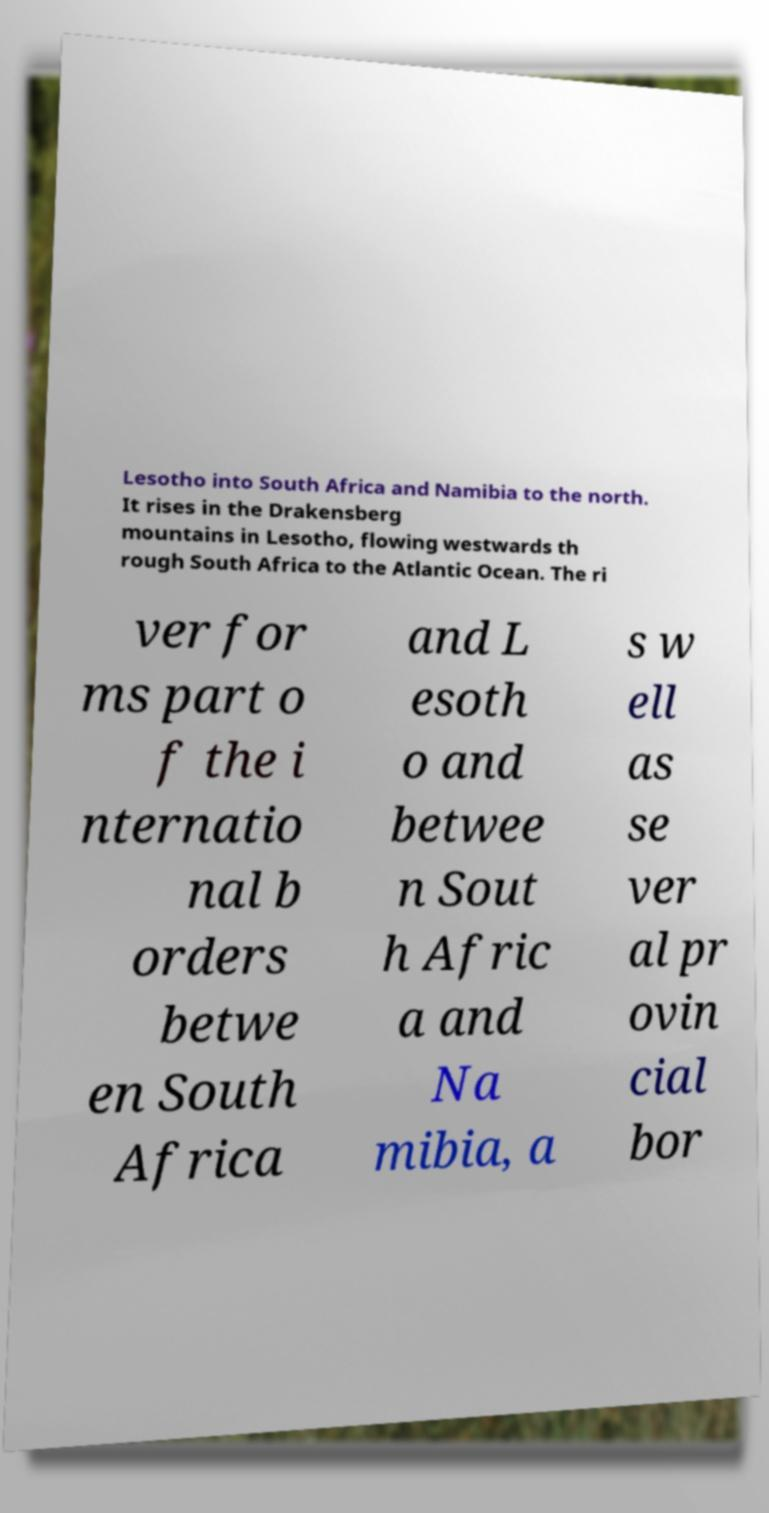There's text embedded in this image that I need extracted. Can you transcribe it verbatim? Lesotho into South Africa and Namibia to the north. It rises in the Drakensberg mountains in Lesotho, flowing westwards th rough South Africa to the Atlantic Ocean. The ri ver for ms part o f the i nternatio nal b orders betwe en South Africa and L esoth o and betwee n Sout h Afric a and Na mibia, a s w ell as se ver al pr ovin cial bor 